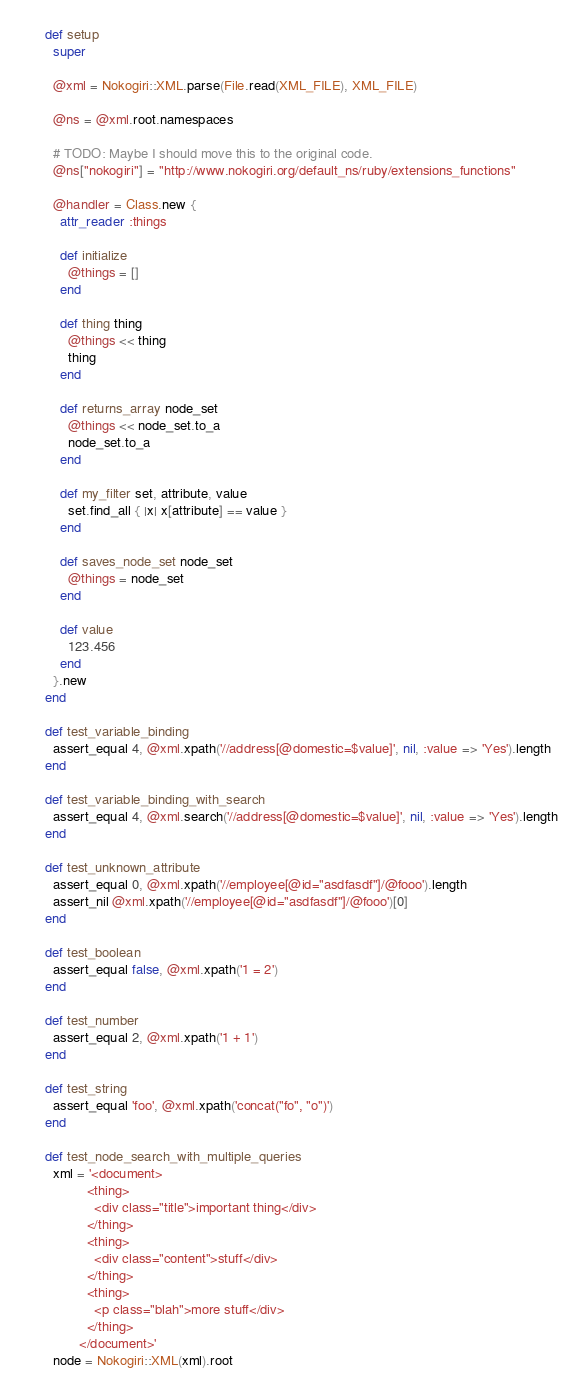Convert code to text. <code><loc_0><loc_0><loc_500><loc_500><_Ruby_>      def setup
        super

        @xml = Nokogiri::XML.parse(File.read(XML_FILE), XML_FILE)

        @ns = @xml.root.namespaces

        # TODO: Maybe I should move this to the original code.
        @ns["nokogiri"] = "http://www.nokogiri.org/default_ns/ruby/extensions_functions"

        @handler = Class.new {
          attr_reader :things

          def initialize
            @things = []
          end

          def thing thing
            @things << thing
            thing
          end

          def returns_array node_set
            @things << node_set.to_a
            node_set.to_a
          end

          def my_filter set, attribute, value
            set.find_all { |x| x[attribute] == value }
          end

          def saves_node_set node_set
            @things = node_set
          end

          def value
            123.456
          end
        }.new
      end

      def test_variable_binding
        assert_equal 4, @xml.xpath('//address[@domestic=$value]', nil, :value => 'Yes').length
      end

      def test_variable_binding_with_search
        assert_equal 4, @xml.search('//address[@domestic=$value]', nil, :value => 'Yes').length
      end

      def test_unknown_attribute
        assert_equal 0, @xml.xpath('//employee[@id="asdfasdf"]/@fooo').length
        assert_nil @xml.xpath('//employee[@id="asdfasdf"]/@fooo')[0]
      end

      def test_boolean
        assert_equal false, @xml.xpath('1 = 2')
      end

      def test_number
        assert_equal 2, @xml.xpath('1 + 1')
      end

      def test_string
        assert_equal 'foo', @xml.xpath('concat("fo", "o")')
      end

      def test_node_search_with_multiple_queries
        xml = '<document>
                 <thing>
                   <div class="title">important thing</div>
                 </thing>
                 <thing>
                   <div class="content">stuff</div>
                 </thing>
                 <thing>
                   <p class="blah">more stuff</div>
                 </thing>
               </document>'
        node = Nokogiri::XML(xml).root</code> 